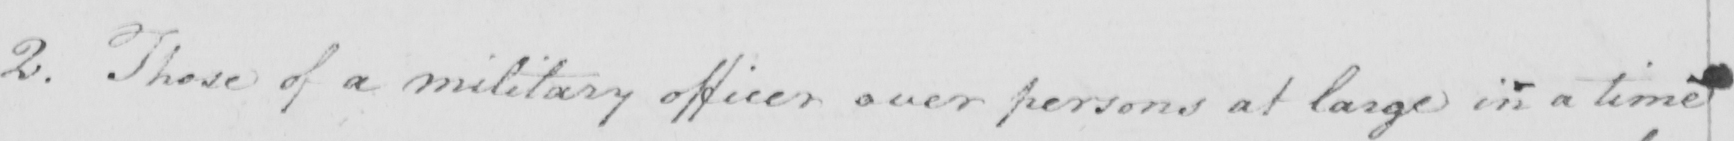Can you tell me what this handwritten text says? 2 . Those of a military officer over persons at large in a time 